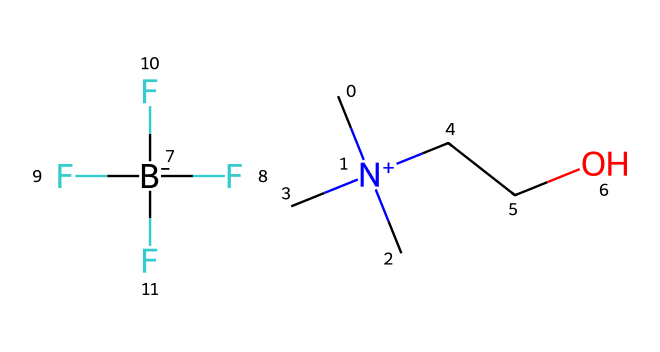What is the total number of carbon atoms in this chemical? By analyzing the SMILES representation, C[N+](C)(C)CCO.[B-](F)(F)(F)F, we can count the carbon atoms. There are three in the nitrogen-containing group (C[N+](C)(C)), two in the CC part before the oxygen, making a total of five carbon atoms.
Answer: five What type of ions make up this ionic liquid? The chemical contains a quaternary ammonium cation represented by C[N+](C)(C)CCO and a tetrafluoroborate anion represented by [B-](F)(F)(F)F. This indicates that the cation is derived from a nitrogen atom, while the anion consists of a boron atom surrounded by four fluorine atoms.
Answer: quaternary ammonium cation and tetrafluoroborate anion How many fluorine atoms are present in this ionic liquid? The anion part of the ionic liquid, [B-](F)(F)(F)F, indicates that there are four fluorine atoms connected to the boron atom (B). Counting those gives a total of four fluorine atoms in this structure.
Answer: four What functional group is present in the cation component of this ionic liquid? The cation part C[N+](C)(C)CCO has an alcohol functional group, which is characterized by the presence of the hydroxyl group (-OH) represented by the "O" in the structure, as seen in the CC-O portion.
Answer: alcohol What is the net charge of the overall ionic liquid? In the given SMILES, the cation is positively charged (N+), and the anion is negatively charged (B-). The overall charge is neutral as the positive and negative charges cancel each other out. Thus, the net charge is zero.
Answer: zero Which part of the molecular structure indicates its potential as a lubricant? The presence of the long hydrocarbon chain and the functional groups seen in the cation (C[N+](C)(C)CCO) suggest its potential as a lubricant due to low volatility and good thermal stability, typical in ionic liquids.
Answer: hydrocarbon chain How many distinct types of atoms are identified in this ionic liquid structure? Reviewing the SMILES representation, we can identify the unique types of atoms: carbon (C), nitrogen (N), oxygen (O), boron (B), and fluorine (F). This totals to five distinct types of atoms.
Answer: five 